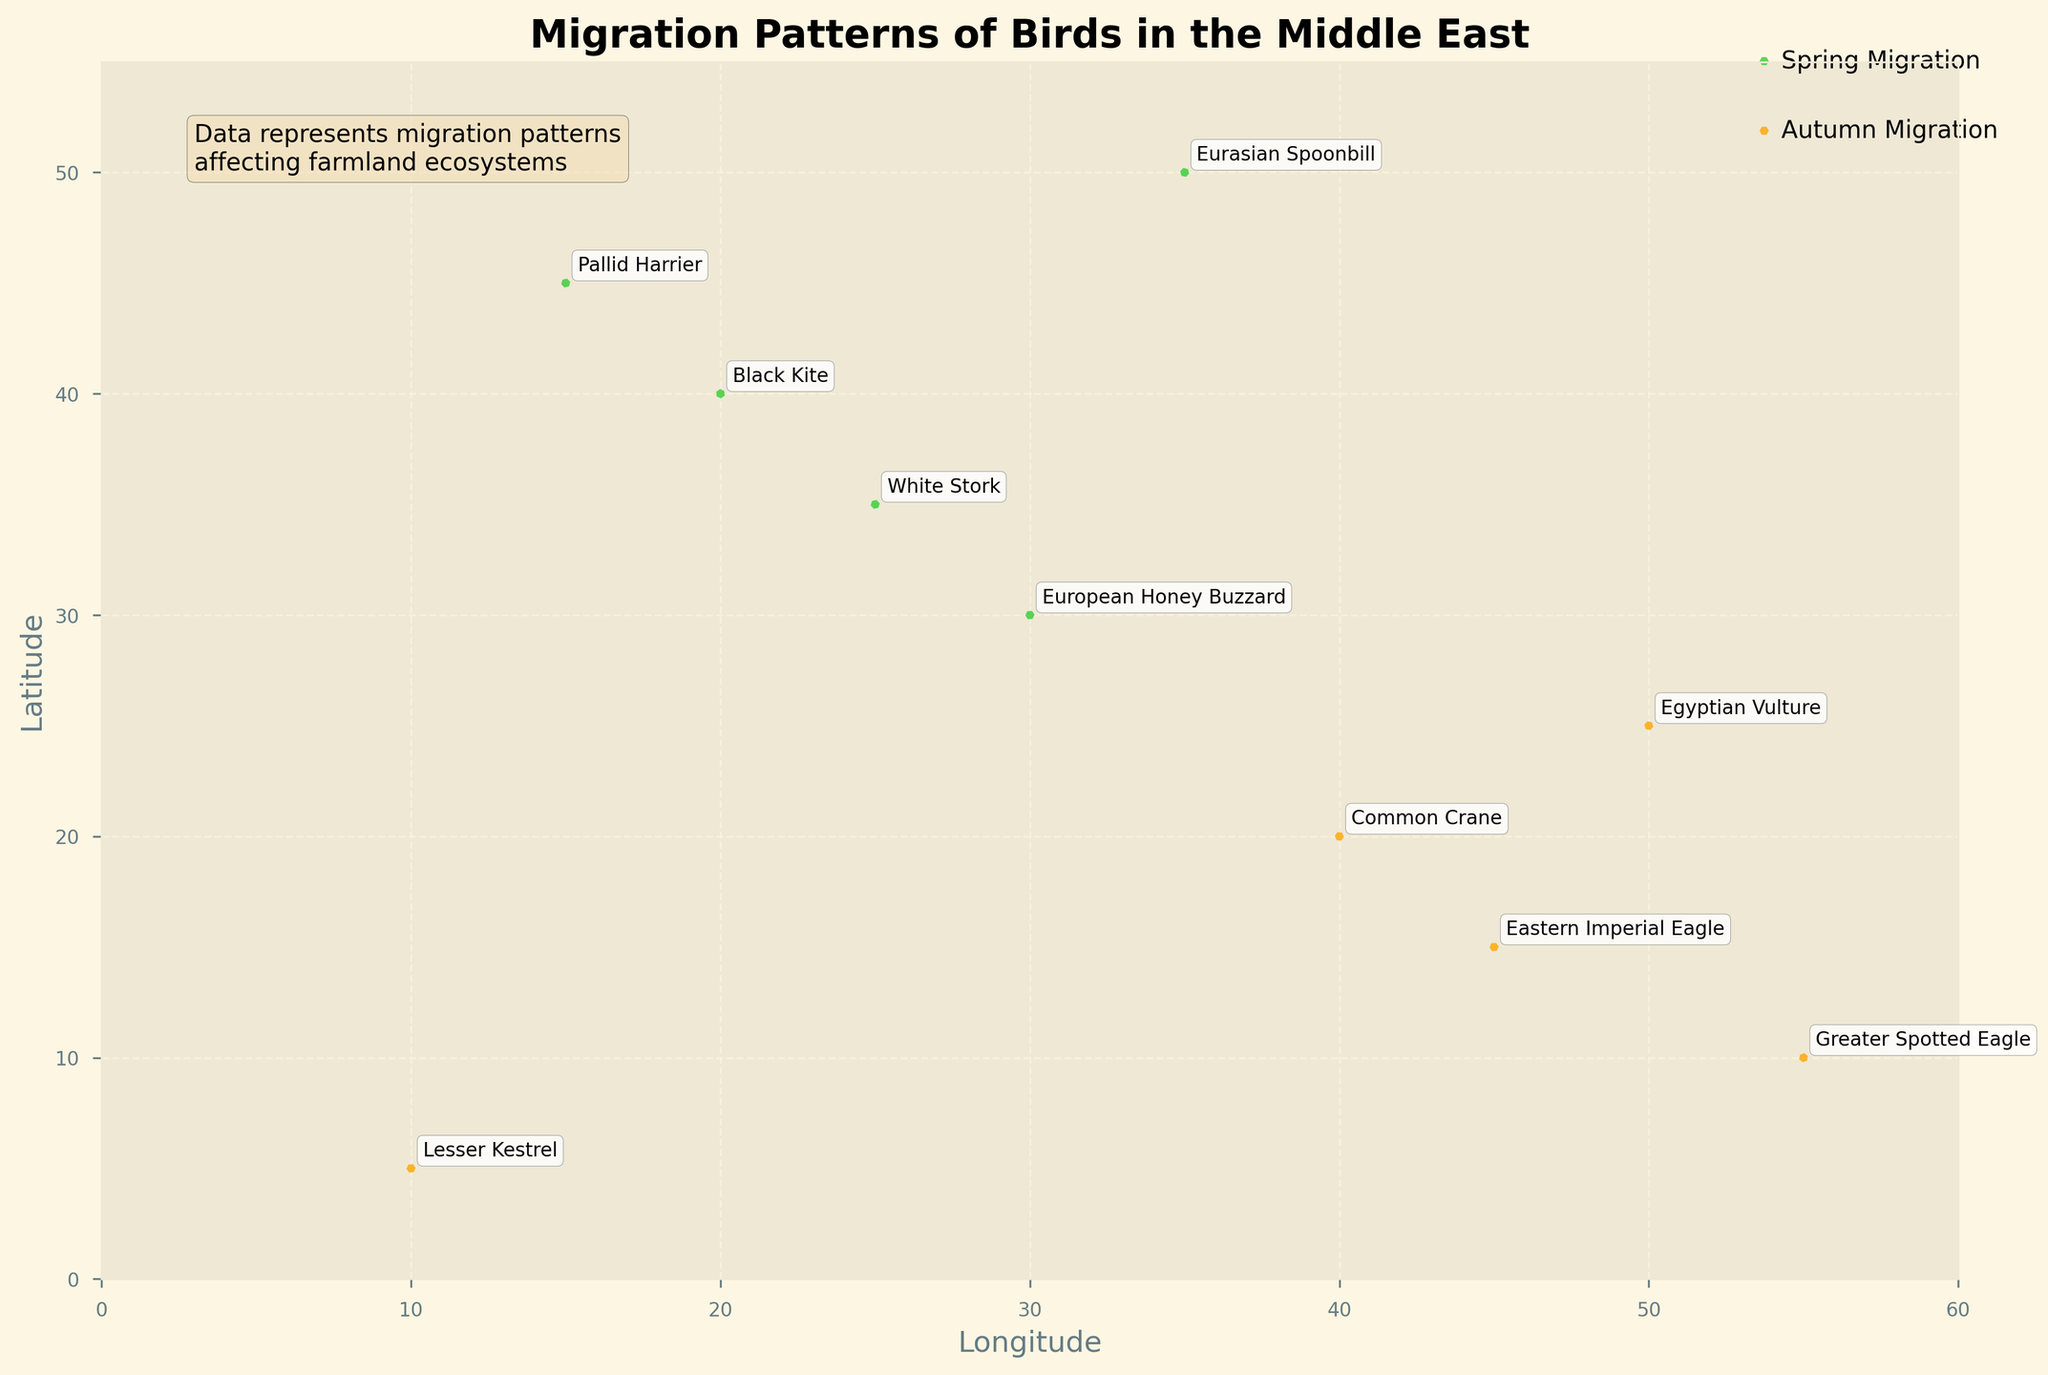What's the title of the figure? The title of the figure is prominently displayed at the top center of the plot, written in bold text.
Answer: Migration Patterns of Birds in the Middle East How many migratory birds were studied in the spring season? The spring data points are indicated by the lime green arrows, representing five different species.
Answer: 5 Which species has a migration pattern towards the north-east during spring? A north-east direction is represented by positive x and y components. The Black Kite has a migration vector (2, 2) towards north-east during spring.
Answer: Black Kite Which species migrates the longest distance in the autumn season? The migration distance can be inferred by calculating the magnitude of the vectors. The Lesser Kestrel has the vector (1, 3), with the magnitude being sqrt(1^2 + 3^2) = sqrt(10), which is the highest among autumn vectors.
Answer: Lesser Kestrel What is the color denotation for spring and autumn migrations in the plot? The plot uses lime green for spring migrations and orange for autumn migrations, as indicated by the legend.
Answer: Spring is lime green, Autumn is orange Which species migrate in the opposite direction during autumn, compared to the White Stork in spring? The White Stork in spring moves in the (2, -3) direction. The Greater Spotted Eagle in autumn moves in the (-2, -1) direction, which is generally opposite.
Answer: Greater Spotted Eagle By how much is the latitude value of the Eurasian Spoonbill higher than the European Honey Buzzard in spring? The Eurasian Spoonbill's latitude is 50, while the European Honey Buzzard's is 30. The difference is calculated as 50 - 30.
Answer: 20 How many species in the spring season have a positive y-component in their migration vector? A positive y-component indicates a northward movement. Both the Pallid Harrier (3, 1) and the Black Kite (2, 2) move northward in the spring season.
Answer: 2 Which species migrate southeastwards during autumn? Southeastward migration can be represented by a negative x-component and positive y-component. The Lesser Kestrel (1, 3) migrates southeastwards during autumn.
Answer: Lesser Kestrel 